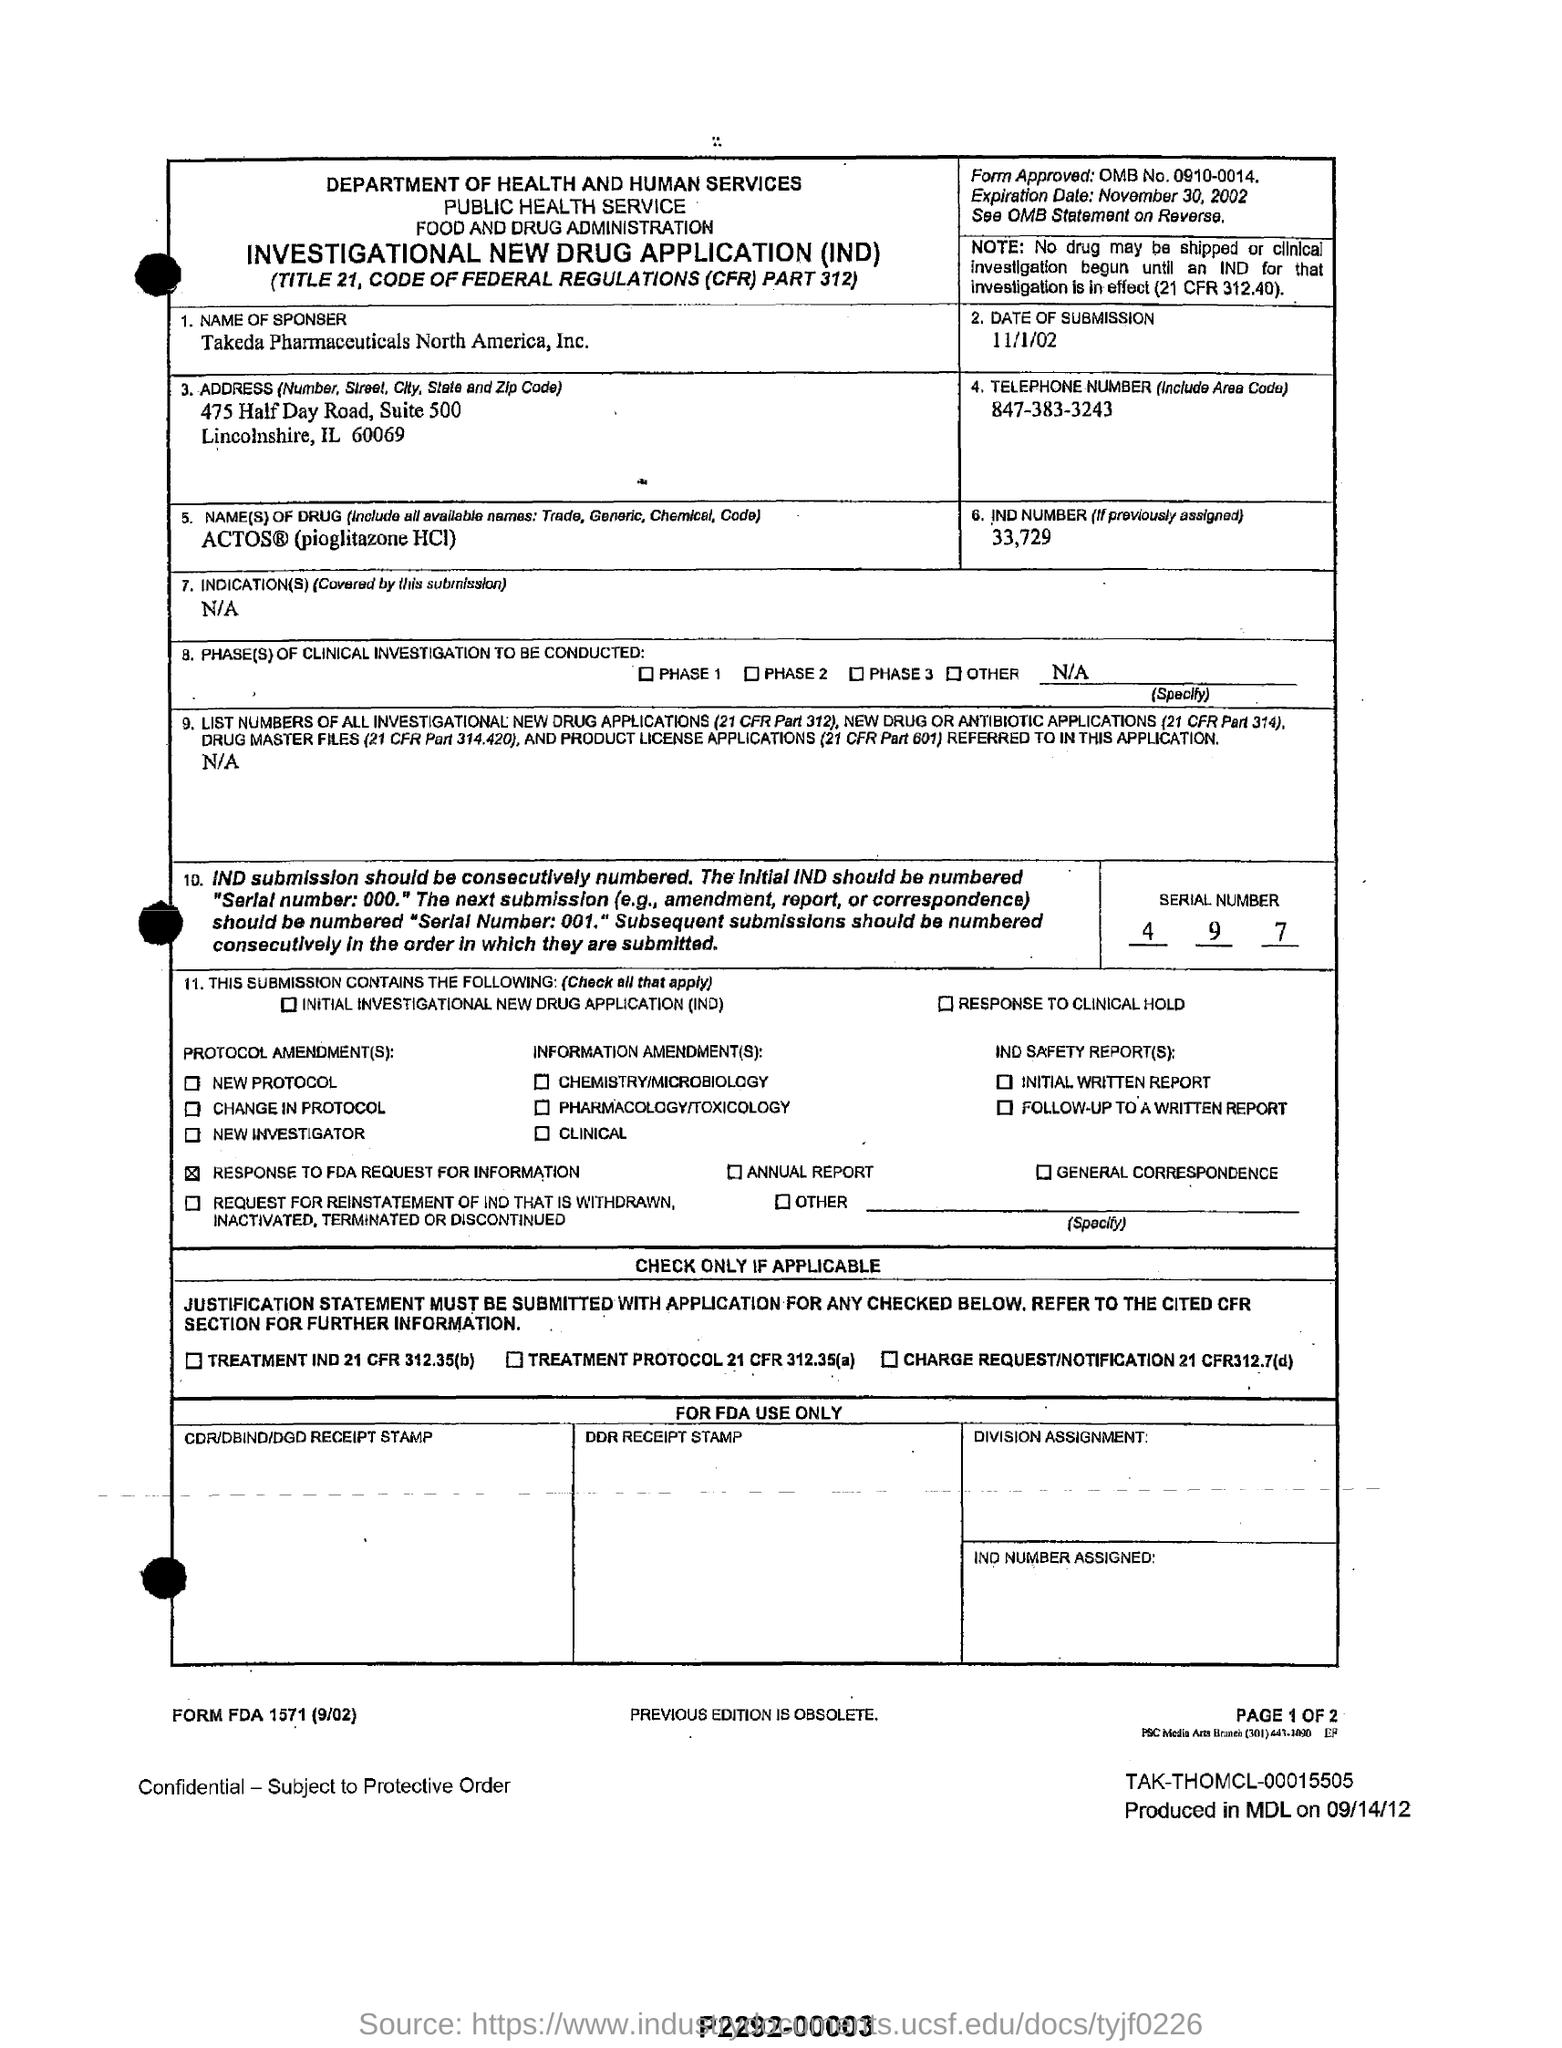What is the ind mumber (if previously assigned ) ?
Make the answer very short. 33,729. What is the serial number mentioned in the form?
Your answer should be very brief. 4 9 7. What is the date of submission ?
Your answer should be compact. 11/1/02. What is the name(s) of drug (include all available names: trade , generic, chemical, code)?
Keep it short and to the point. ACTOS (pioglitazone HCI). What is the form approved : omb no
Your answer should be very brief. 0910-0014. 